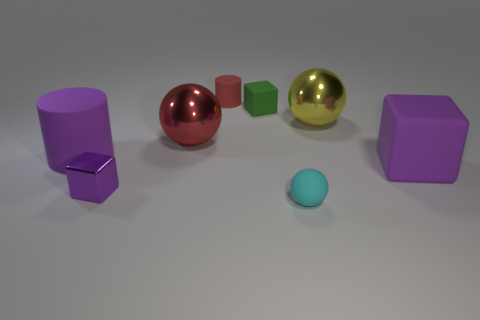Is there a large object that has the same color as the large matte cylinder?
Your answer should be compact. Yes. What material is the cyan thing?
Your answer should be compact. Rubber. How many objects are large cyan cylinders or yellow objects?
Your answer should be compact. 1. There is a block that is behind the big purple matte block; what size is it?
Offer a very short reply. Small. How many other things are the same material as the big purple block?
Offer a terse response. 4. There is a cube left of the small red thing; is there a rubber cylinder in front of it?
Make the answer very short. No. Is there any other thing that is the same shape as the tiny green thing?
Provide a succinct answer. Yes. What is the color of the tiny thing that is the same shape as the large yellow thing?
Your response must be concise. Cyan. How big is the yellow metal sphere?
Your answer should be compact. Large. Is the number of big red metallic spheres that are right of the tiny green matte block less than the number of tiny cyan matte things?
Your answer should be compact. Yes. 